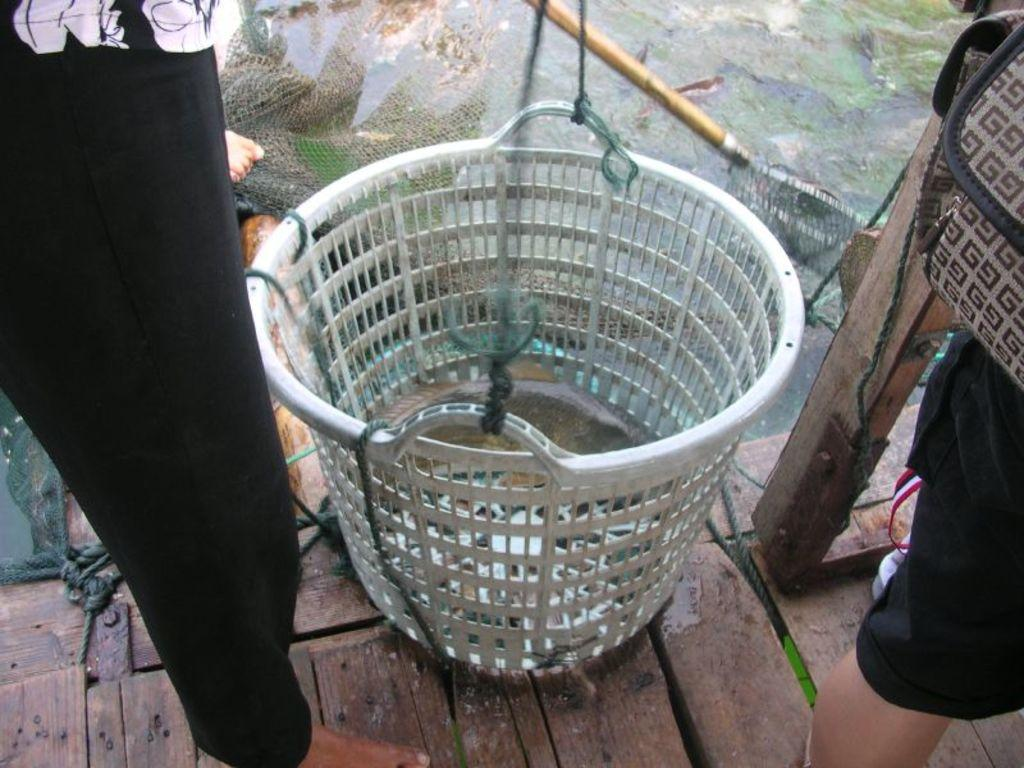What object can be seen in the image that might be used for carrying items? There is a basket in the image that could be used for carrying items. How many people are present in the image? There are two people in the image. What activity are the people engaged in? The people are fishing with nets in the water. What type of surface is visible in the image? There is a water surface visible in the image. What type of scarf is being used to cook in the oven in the image? There is no scarf or oven present in the image; it features a basket and people fishing with nets in the water. 